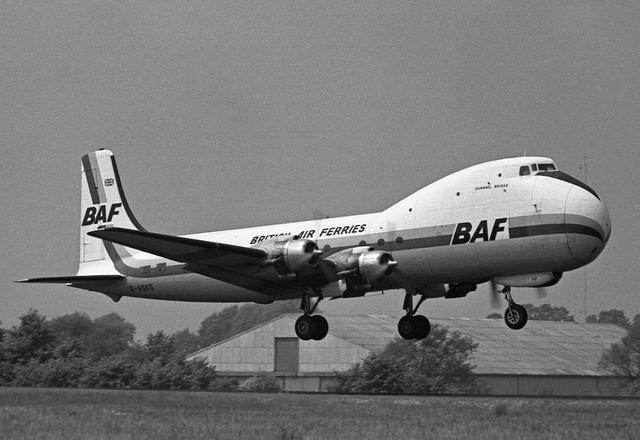How many tires are there?
Give a very brief answer. 5. How many airplanes are in the photo?
Give a very brief answer. 1. 